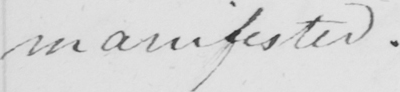What is written in this line of handwriting? manifested . 